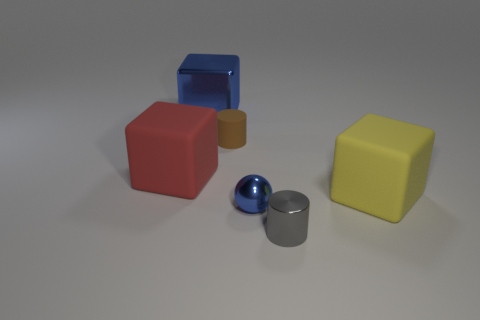There is a sphere; is its color the same as the metal thing that is behind the large yellow thing?
Offer a terse response. Yes. There is a object that is the same color as the ball; what size is it?
Give a very brief answer. Large. What is the material of the tiny ball that is the same color as the large metallic thing?
Make the answer very short. Metal. What shape is the small thing in front of the blue object that is in front of the big red block?
Your response must be concise. Cylinder. Are there any brown cubes that have the same size as the sphere?
Give a very brief answer. No. Is the number of large red matte cubes greater than the number of big cyan matte blocks?
Ensure brevity in your answer.  Yes. There is a blue metal object that is behind the tiny blue thing; is it the same size as the metallic ball that is left of the tiny gray shiny object?
Ensure brevity in your answer.  No. How many blue metal things are both to the left of the metallic ball and in front of the large blue metal block?
Ensure brevity in your answer.  0. There is a metallic thing that is the same shape as the red rubber thing; what is its color?
Your answer should be compact. Blue. Is the number of balls less than the number of large red shiny objects?
Offer a terse response. No. 